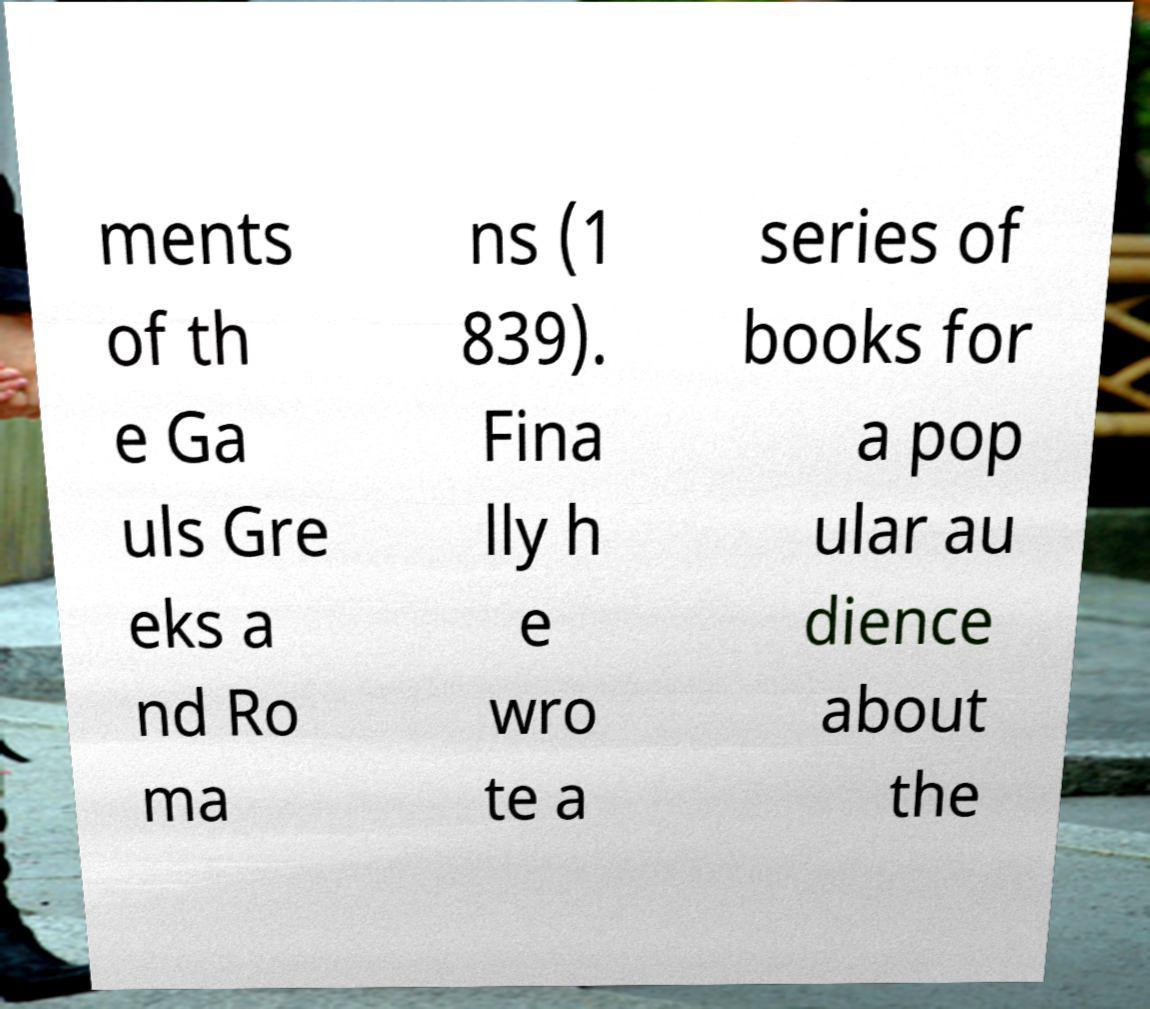I need the written content from this picture converted into text. Can you do that? ments of th e Ga uls Gre eks a nd Ro ma ns (1 839). Fina lly h e wro te a series of books for a pop ular au dience about the 